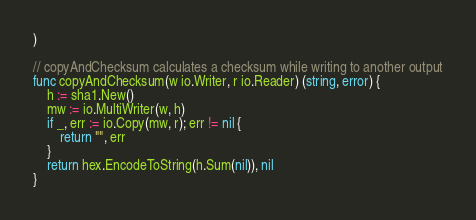<code> <loc_0><loc_0><loc_500><loc_500><_Go_>)

// copyAndChecksum calculates a checksum while writing to another output
func copyAndChecksum(w io.Writer, r io.Reader) (string, error) {
	h := sha1.New()
	mw := io.MultiWriter(w, h)
	if _, err := io.Copy(mw, r); err != nil {
		return "", err
	}
	return hex.EncodeToString(h.Sum(nil)), nil
}
</code> 